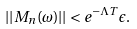<formula> <loc_0><loc_0><loc_500><loc_500>| | M _ { n } ( \omega ) | | < e ^ { - \Lambda T } \epsilon .</formula> 